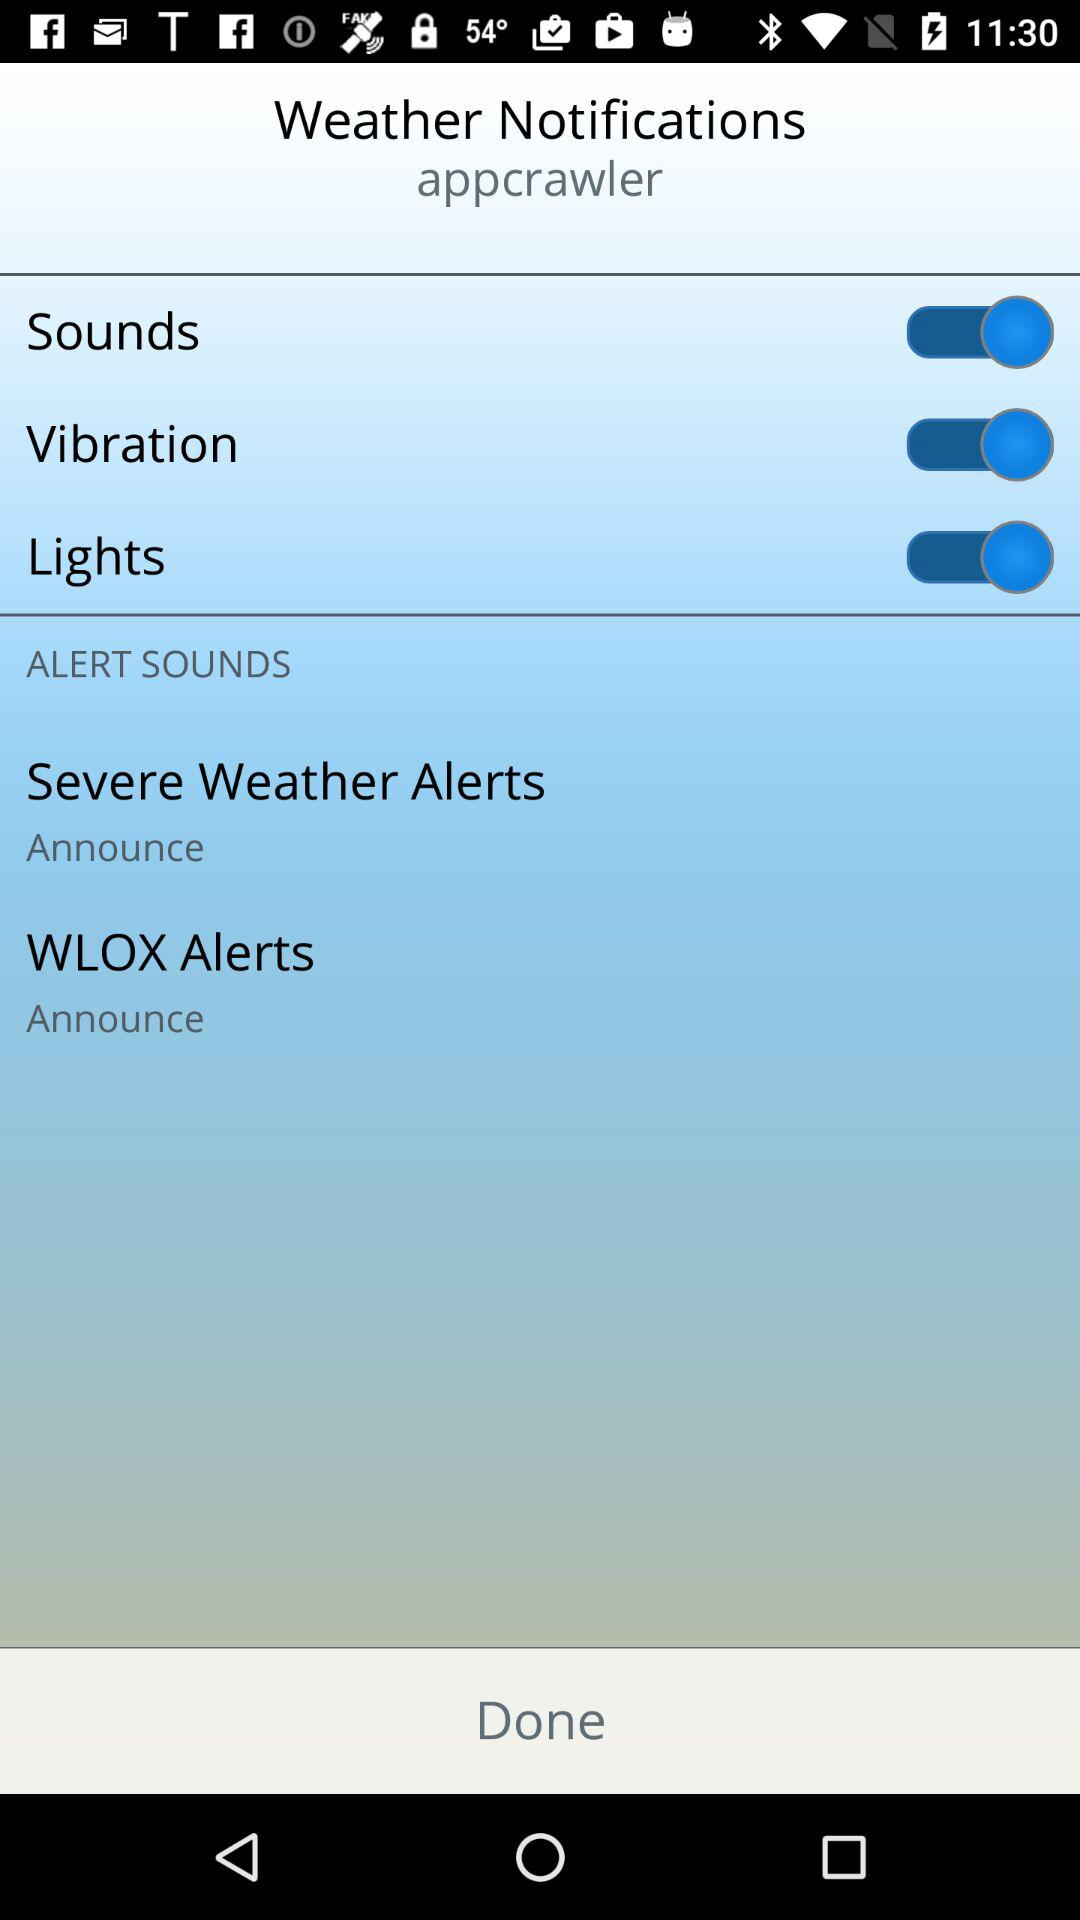Will severe weather alerts be declared or not?
When the provided information is insufficient, respond with <no answer>. <no answer> 